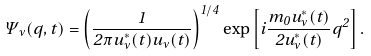<formula> <loc_0><loc_0><loc_500><loc_500>\Psi _ { \nu } ( q , t ) = \left ( \frac { 1 } { 2 \pi u ^ { * } _ { \nu } ( t ) u _ { \nu } ( t ) } \right ) ^ { 1 / 4 } \exp \left [ i \frac { m _ { 0 } \dot { u } ^ { * } _ { \nu } ( t ) } { 2 u ^ { * } _ { \nu } ( t ) } q ^ { 2 } \right ] .</formula> 